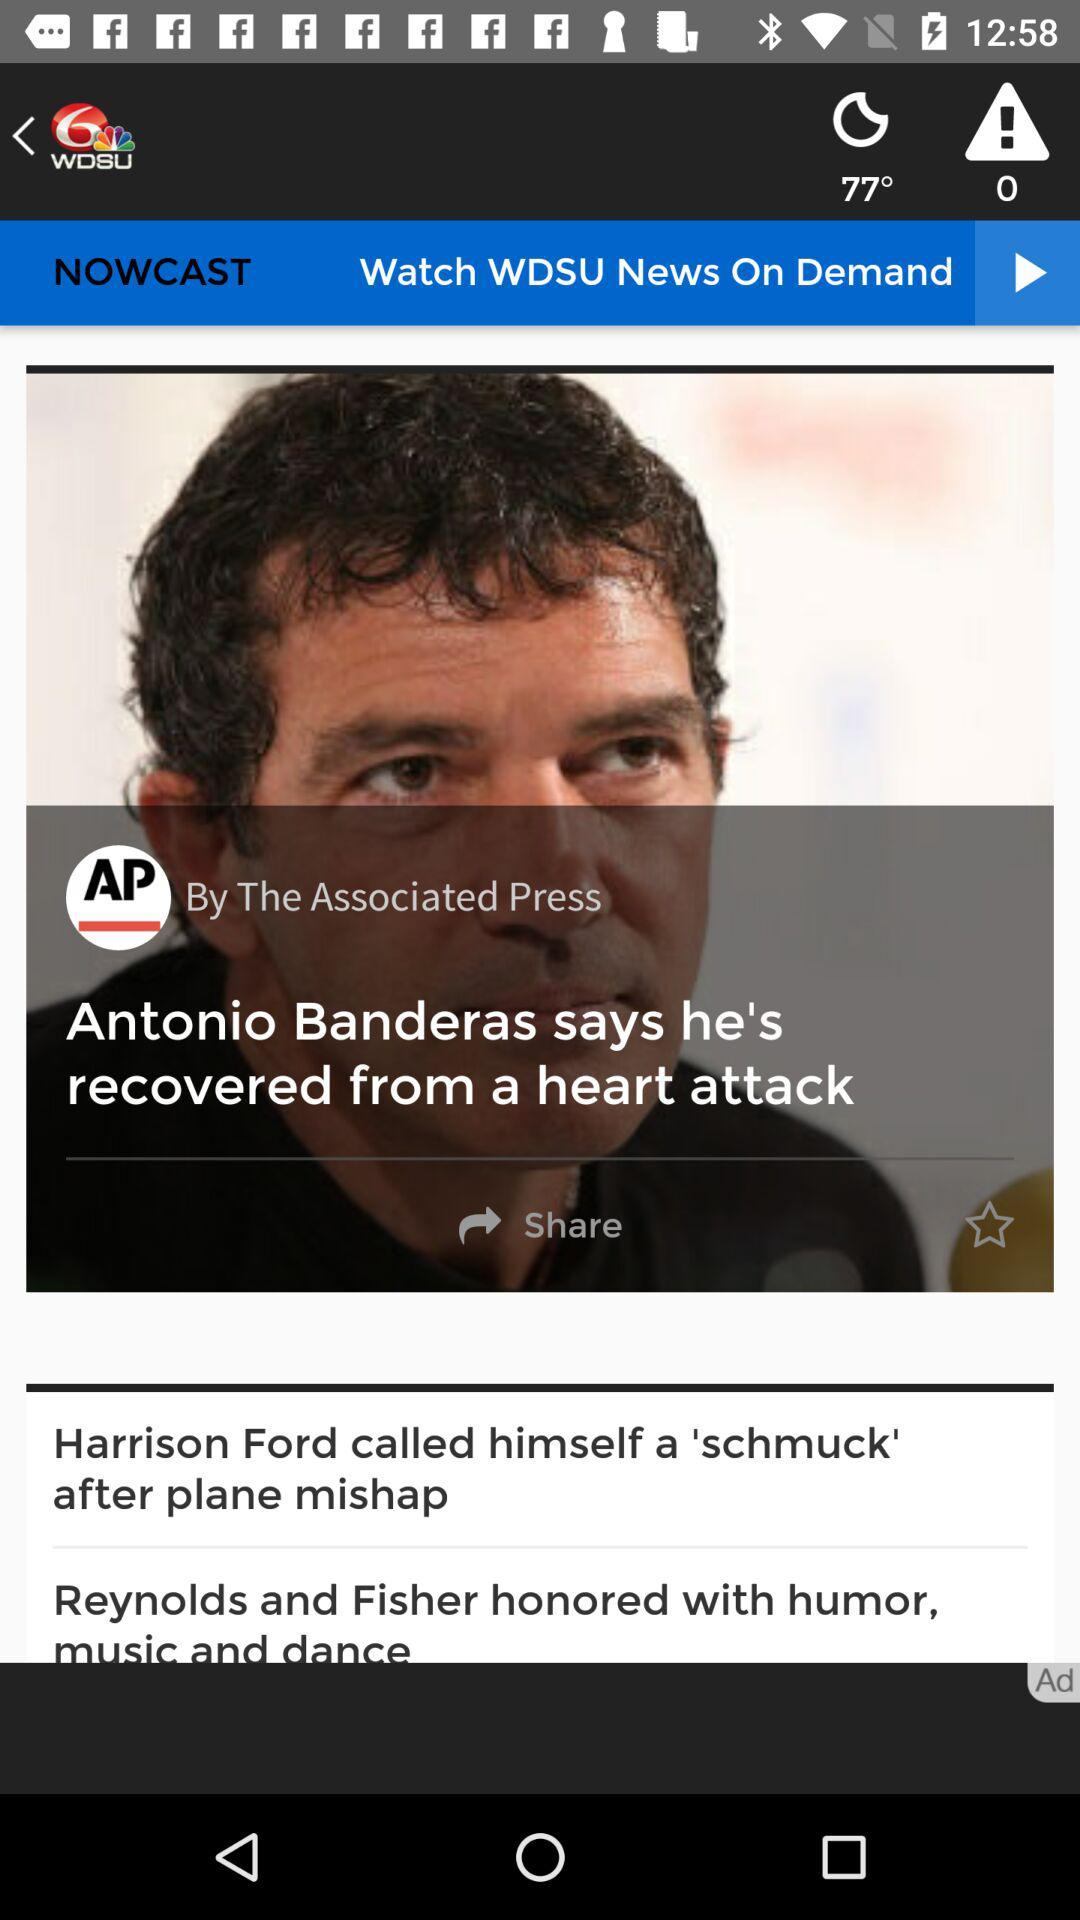How many alerts are there? There are 0 alerts. 